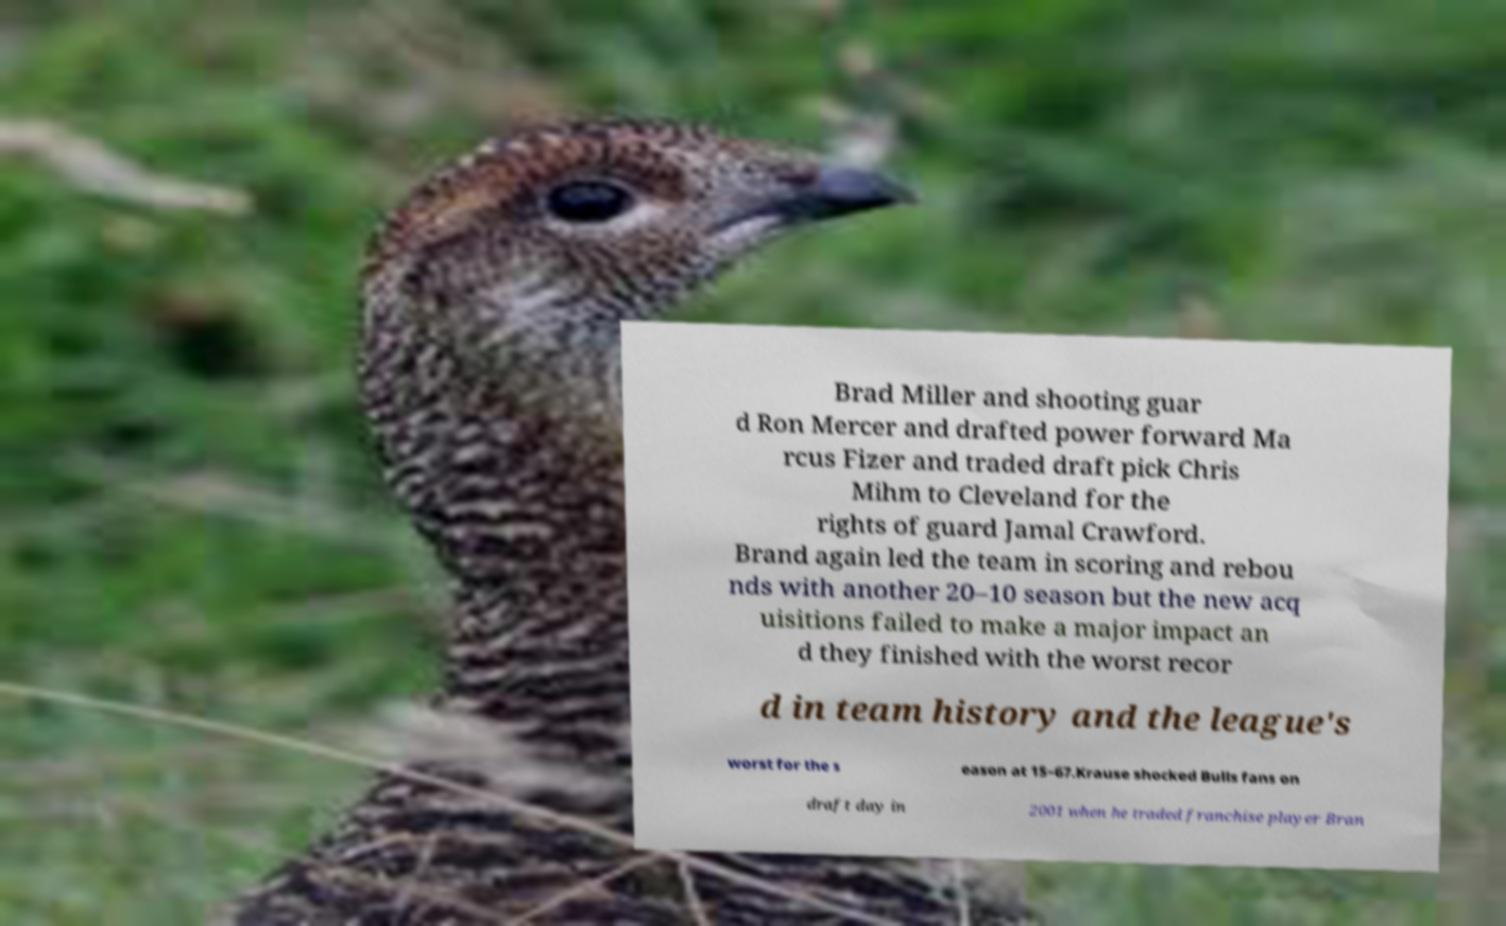Please identify and transcribe the text found in this image. Brad Miller and shooting guar d Ron Mercer and drafted power forward Ma rcus Fizer and traded draft pick Chris Mihm to Cleveland for the rights of guard Jamal Crawford. Brand again led the team in scoring and rebou nds with another 20–10 season but the new acq uisitions failed to make a major impact an d they finished with the worst recor d in team history and the league's worst for the s eason at 15–67.Krause shocked Bulls fans on draft day in 2001 when he traded franchise player Bran 